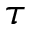Convert formula to latex. <formula><loc_0><loc_0><loc_500><loc_500>\tau</formula> 